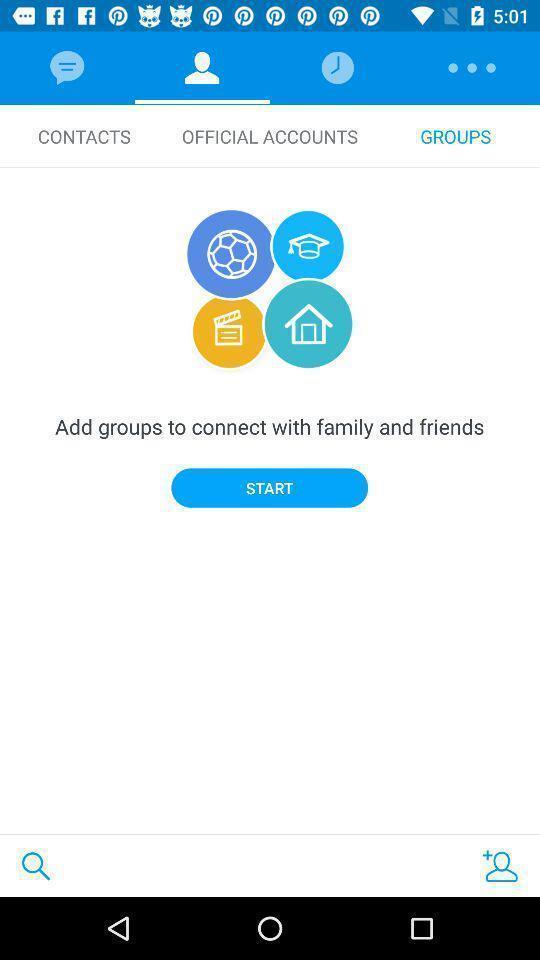Describe the key features of this screenshot. Page showing home page. 